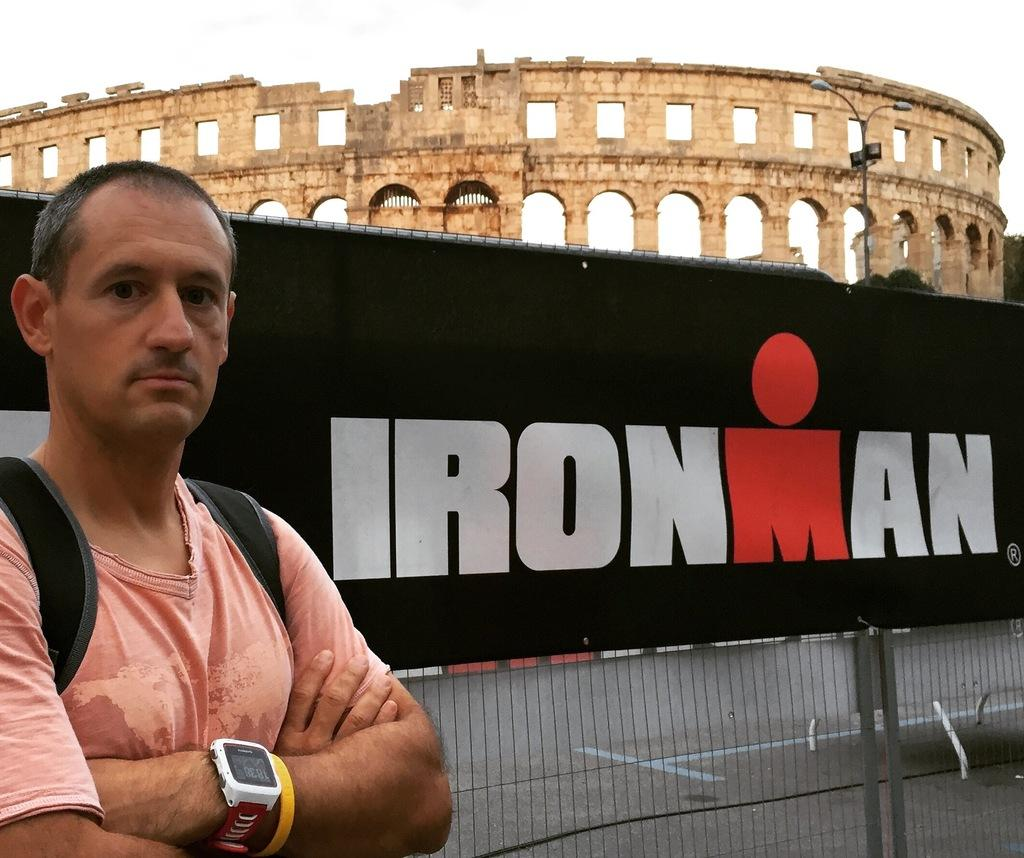<image>
Relay a brief, clear account of the picture shown. A man wearing a backpack stands next to an Ironman banner in front of an old Colosseum. 